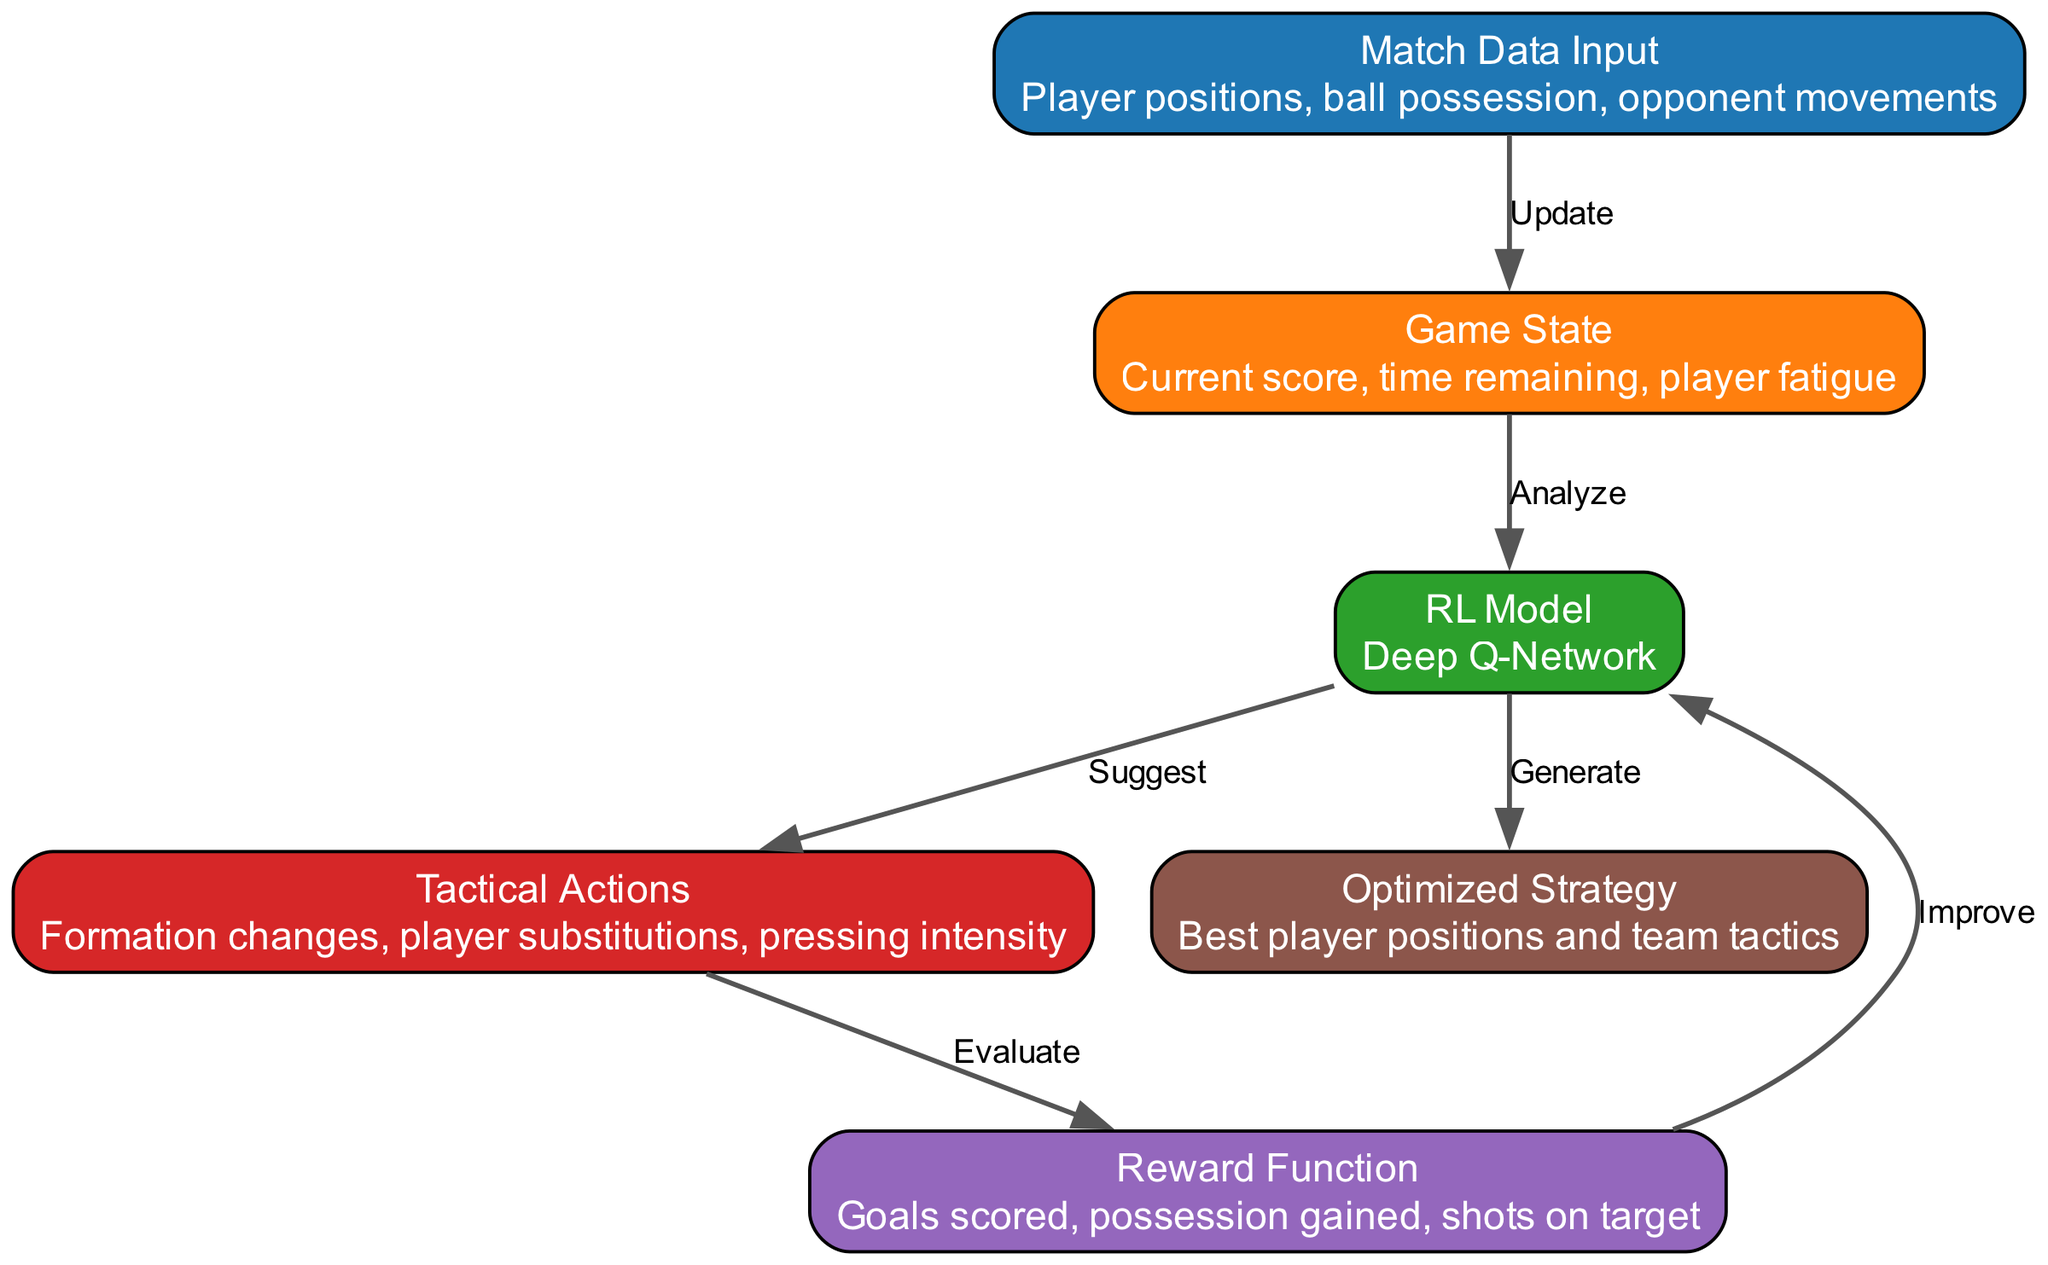What's the label of the first node in the diagram? The first node in the diagram is labeled "Match Data Input". This can be identified as the first element listed in the nodes section of the data, which is recognized easily by the hierarchical presentation of nodes in the diagram.
Answer: Match Data Input How many nodes are in the diagram? The diagram contains six nodes as shown in the nodes section of the data. Each entry in this section represents a unique node for the diagram structure.
Answer: Six What is the reward function based on the diagram? The reward function is defined as "Goals scored, possession gained, shots on target". This is taken directly from the details section of the reward node, indicating what metrics contribute to the evaluation of actions.
Answer: Goals scored, possession gained, shots on target Which node analyzes the game state? The node that analyzes the game state is the "RL Model", which is indicated by the edge connecting "Game State" to "RL Model" labeled "Analyze". This shows that the model processes the current game state information.
Answer: RL Model What is the output generated by the model? The output generated by the model is "Optimized Strategy". This is connected to the model node via the edge labeled "Generate", indicating that the model's computations result in optimal tactical instructions for the team.
Answer: Optimized Strategy What relationship is present between the reward function and the model? The relationship between the reward function and the model is that the reward function is used to "Improve" the model. This is depicted in the edge from the reward node to the model node, showing that feedback from rewards influences model adjustments.
Answer: Improve Which node suggests tactical actions? The node that suggests tactical actions is the "RL Model". This can be inferred from the edge leading from the model to the action node, marked "Suggest", indicating its role in recommending strategies based on the state analysis.
Answer: RL Model What updates the game state in the diagram? The game state is updated by the "Match Data Input". This is evident from the edge that leads from the input node to the state node, labeled "Update", which represents the flow of input data into the current game state evaluation.
Answer: Match Data Input How does the model generate output in the diagram? The model generates output through the process of analyzing the current game state and then suggesting tactical actions based on the situation at hand, finally leading to optimized strategy as indicated by the connection labeled "Generate".
Answer: Generate 